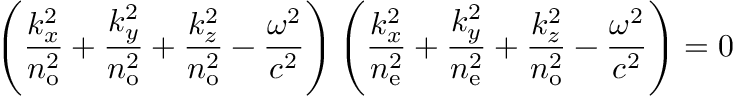<formula> <loc_0><loc_0><loc_500><loc_500>\left ( { \frac { k _ { x } ^ { 2 } } { n _ { o } ^ { 2 } } } + { \frac { k _ { y } ^ { 2 } } { n _ { o } ^ { 2 } } } + { \frac { k _ { z } ^ { 2 } } { n _ { o } ^ { 2 } } } - { \frac { \omega ^ { 2 } } { c ^ { 2 } } } \right ) \left ( { \frac { k _ { x } ^ { 2 } } { n _ { e } ^ { 2 } } } + { \frac { k _ { y } ^ { 2 } } { n _ { e } ^ { 2 } } } + { \frac { k _ { z } ^ { 2 } } { n _ { o } ^ { 2 } } } - { \frac { \omega ^ { 2 } } { c ^ { 2 } } } \right ) = 0</formula> 